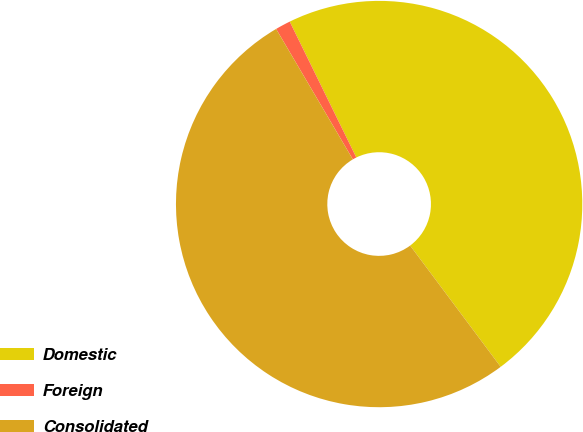Convert chart. <chart><loc_0><loc_0><loc_500><loc_500><pie_chart><fcel>Domestic<fcel>Foreign<fcel>Consolidated<nl><fcel>47.05%<fcel>1.21%<fcel>51.75%<nl></chart> 